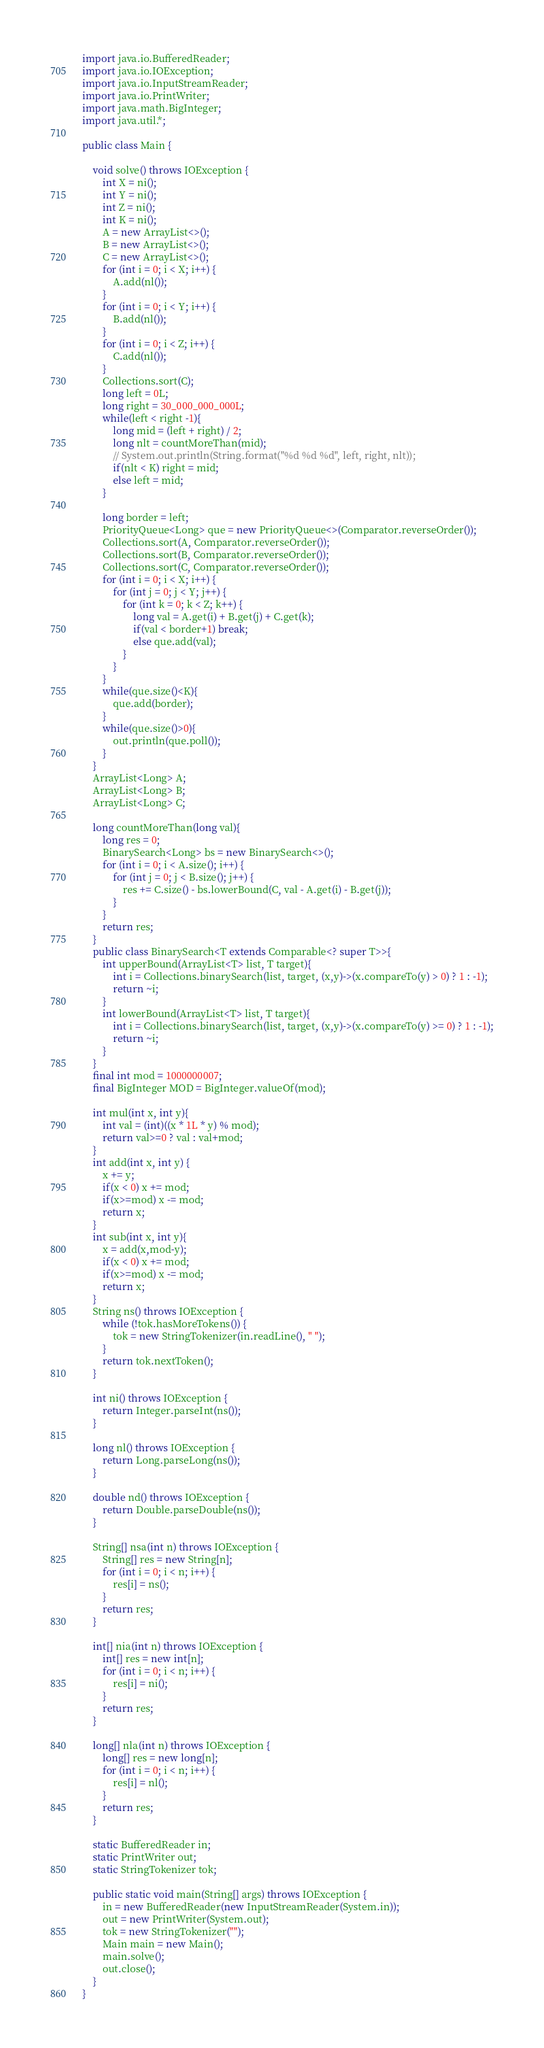Convert code to text. <code><loc_0><loc_0><loc_500><loc_500><_Java_>import java.io.BufferedReader;
import java.io.IOException;
import java.io.InputStreamReader;
import java.io.PrintWriter;
import java.math.BigInteger;
import java.util.*;
 
public class Main {
 
    void solve() throws IOException {
        int X = ni();
        int Y = ni();
        int Z = ni();
        int K = ni();
        A = new ArrayList<>();
        B = new ArrayList<>();
        C = new ArrayList<>();
        for (int i = 0; i < X; i++) {
            A.add(nl());
        }
        for (int i = 0; i < Y; i++) {
            B.add(nl());
        }
        for (int i = 0; i < Z; i++) {
            C.add(nl());
        }
        Collections.sort(C);
        long left = 0L;
        long right = 30_000_000_000L;
        while(left < right -1){
            long mid = (left + right) / 2;
            long nlt = countMoreThan(mid);
            // System.out.println(String.format("%d %d %d", left, right, nlt));
            if(nlt < K) right = mid;
            else left = mid;
        }

        long border = left;
        PriorityQueue<Long> que = new PriorityQueue<>(Comparator.reverseOrder());
        Collections.sort(A, Comparator.reverseOrder());
        Collections.sort(B, Comparator.reverseOrder());
        Collections.sort(C, Comparator.reverseOrder());
        for (int i = 0; i < X; i++) {
            for (int j = 0; j < Y; j++) {
                for (int k = 0; k < Z; k++) {
                    long val = A.get(i) + B.get(j) + C.get(k);
                    if(val < border+1) break;
                    else que.add(val);
                }
            }
        }
        while(que.size()<K){
            que.add(border);
        }
        while(que.size()>0){
            out.println(que.poll());            
        }
    }
    ArrayList<Long> A;
    ArrayList<Long> B;
    ArrayList<Long> C;

    long countMoreThan(long val){
        long res = 0;
        BinarySearch<Long> bs = new BinarySearch<>();
        for (int i = 0; i < A.size(); i++) {
            for (int j = 0; j < B.size(); j++) {
                res += C.size() - bs.lowerBound(C, val - A.get(i) - B.get(j));
            }
        }
        return res;
    }
    public class BinarySearch<T extends Comparable<? super T>>{
        int upperBound(ArrayList<T> list, T target){
            int i = Collections.binarySearch(list, target, (x,y)->(x.compareTo(y) > 0) ? 1 : -1);
            return ~i;
        }
        int lowerBound(ArrayList<T> list, T target){
            int i = Collections.binarySearch(list, target, (x,y)->(x.compareTo(y) >= 0) ? 1 : -1);
            return ~i;
        }
    }
    final int mod = 1000000007;
    final BigInteger MOD = BigInteger.valueOf(mod);

    int mul(int x, int y){
        int val = (int)((x * 1L * y) % mod);
        return val>=0 ? val : val+mod;
    }
    int add(int x, int y) {
        x += y;
        if(x < 0) x += mod;
        if(x>=mod) x -= mod;
        return x;
    }
    int sub(int x, int y){
        x = add(x,mod-y);
        if(x < 0) x += mod;
        if(x>=mod) x -= mod;
        return x;
    }
    String ns() throws IOException {
        while (!tok.hasMoreTokens()) {
            tok = new StringTokenizer(in.readLine(), " ");
        }
        return tok.nextToken();
    }
 
    int ni() throws IOException {
        return Integer.parseInt(ns());
    }
 
    long nl() throws IOException {
        return Long.parseLong(ns());
    }
 
    double nd() throws IOException {
        return Double.parseDouble(ns());
    }
 
    String[] nsa(int n) throws IOException {
        String[] res = new String[n];
        for (int i = 0; i < n; i++) {
            res[i] = ns();
        }
        return res;
    }
 
    int[] nia(int n) throws IOException {
        int[] res = new int[n];
        for (int i = 0; i < n; i++) {
            res[i] = ni();
        }
        return res;
    }
 
    long[] nla(int n) throws IOException {
        long[] res = new long[n];
        for (int i = 0; i < n; i++) {
            res[i] = nl();
        }
        return res;
    }
 
    static BufferedReader in;
    static PrintWriter out;
    static StringTokenizer tok;
 
    public static void main(String[] args) throws IOException {
        in = new BufferedReader(new InputStreamReader(System.in));
        out = new PrintWriter(System.out);
        tok = new StringTokenizer("");
        Main main = new Main();
        main.solve();
        out.close();
    }
}</code> 